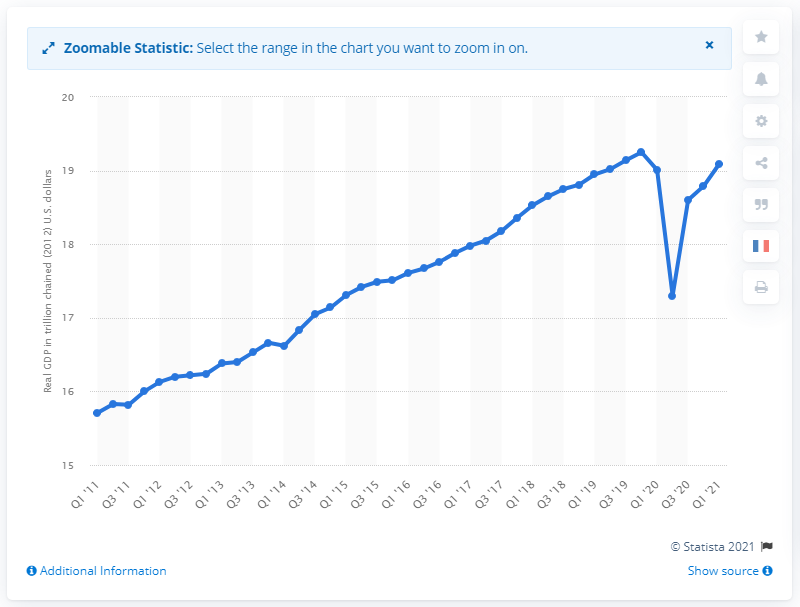Highlight a few significant elements in this photo. The Gross Domestic Product (GDP) of the United States in 2012 was 18.95 trillion dollars. The Gross Domestic Product, or GDP, of the United States in the previous quarter was 18.65. 